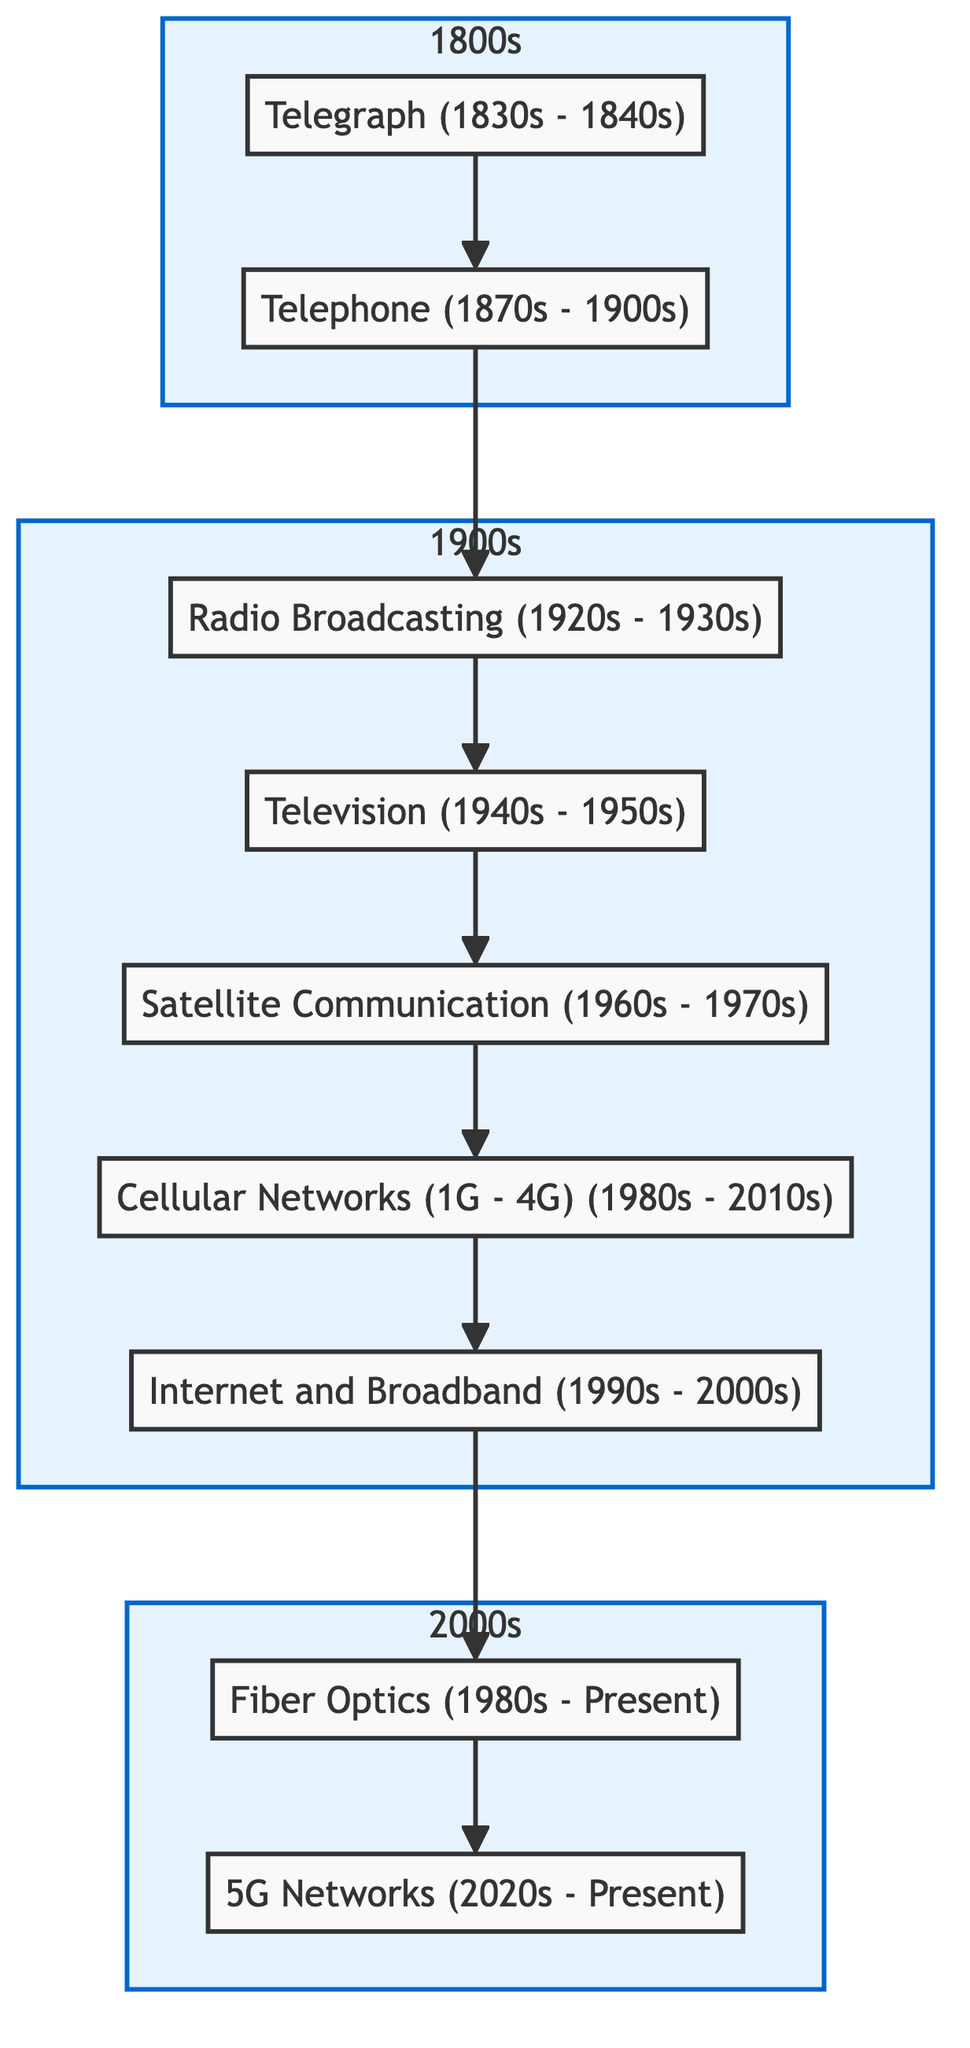What is the earliest telecommunication technology shown in the diagram? The diagram starts with "Telegraph (1830s - 1840s)" which is the first node at the bottom, indicating it is the earliest technology in this flow chart.
Answer: Telegraph (1830s - 1840s) How many telecommunication technologies are listed in the diagram? By counting the nodes included in the diagram, there are a total of nine technologies ranging from telegraph at the bottom to 5G networks at the top.
Answer: 9 Which technology directly follows Radio Broadcasting in the flow? In the diagram, the arrow indicates a direct flow from "Radio Broadcasting (1920s - 1930s)" directly to "Television (1940s - 1950s)".
Answer: Television (1940s - 1950s) What decade is associated with Cellular Networks? The description for "Cellular Networks (1G - 4G)" includes the timeframe "1980s - 2010s", clearly distinguishing the decade related to that technology.
Answer: 1980s - 2010s Which telecommunication technology leads to Internet and Broadband? The flow from "Cellular Networks (1G - 4G)" points to "Internet and Broadband (1990s - 2000s)", showing that cellular technology directly leads to the development of the Internet.
Answer: Cellular Networks (1G - 4G) In what way does 5G Networks improve upon previous technologies? The diagram states that "5G technology offers faster speeds, lower latency, and supports a larger number of connected devices," suggesting enhanced capabilities compared to earlier networks.
Answer: Faster speeds, lower latency Which two technologies were developed during the 1980s? The nodes "Cellular Networks (1G - 4G)" and "Fiber Optics" both have the timeframe "1980s" mentioned under them, indicating that they were developed during that decade.
Answer: Cellular Networks (1G - 4G), Fiber Optics What is the last technology in the flow chart? The diagram concludes with "5G Networks (2020s - Present)", which represents the latest telecommunication technology depicted at the top of the flow chart.
Answer: 5G Networks (2020s - Present) How does satellite communication relate to earlier technologies? The diagram shows an upward connection from "Television (1940s - 1950s)" to "Satellite Communication (1960s - 1970s)", indicating that television technology was followed by satellite communication development.
Answer: Satellite Communication (1960s - 1970s) 